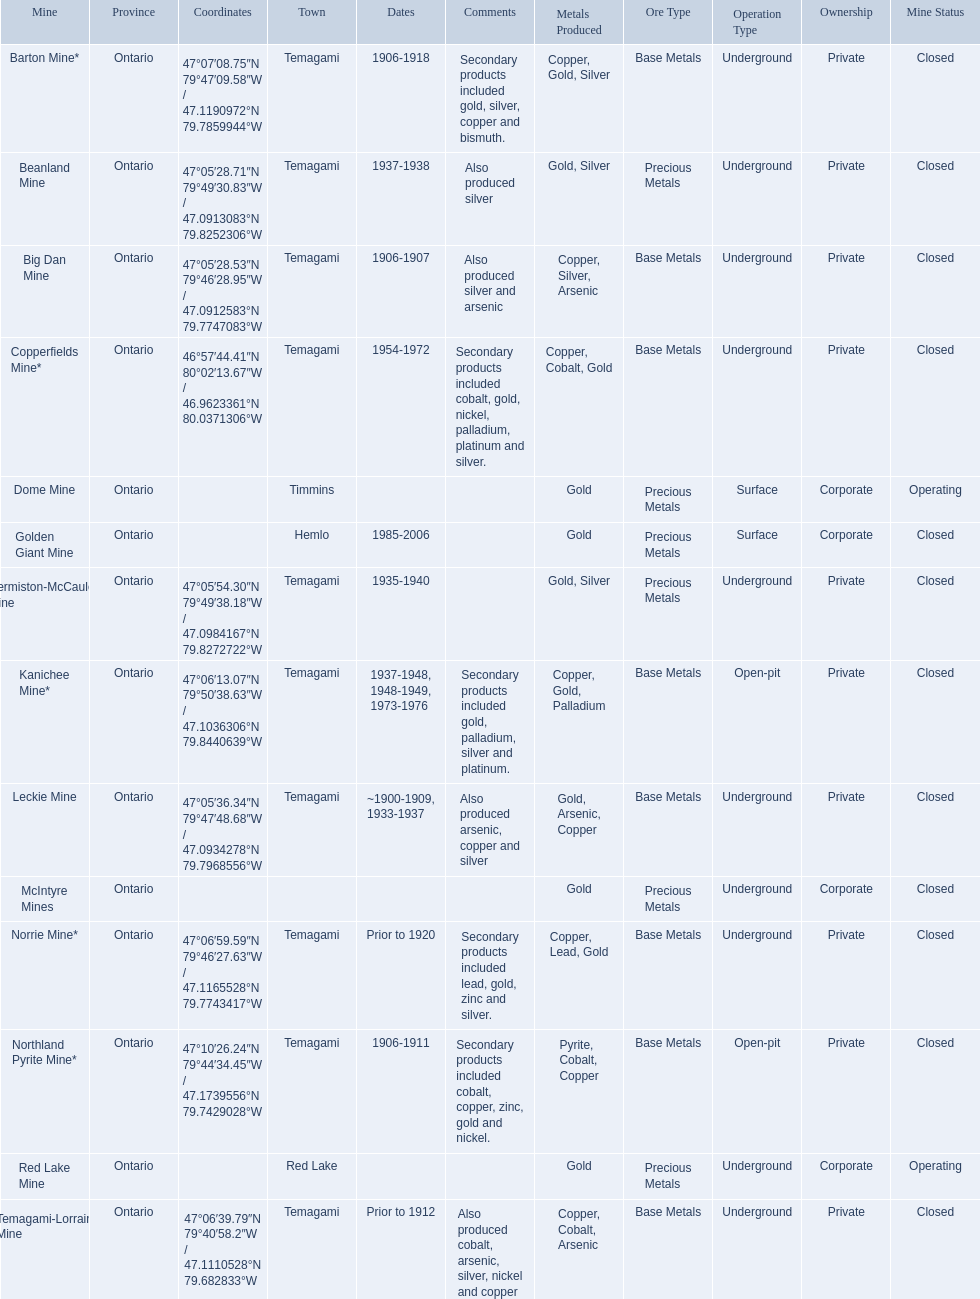What dates was the golden giant mine open? 1985-2006. What dates was the beanland mine open? 1937-1938. Of those mines, which was open longer? Golden Giant Mine. 